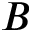<formula> <loc_0><loc_0><loc_500><loc_500>B</formula> 